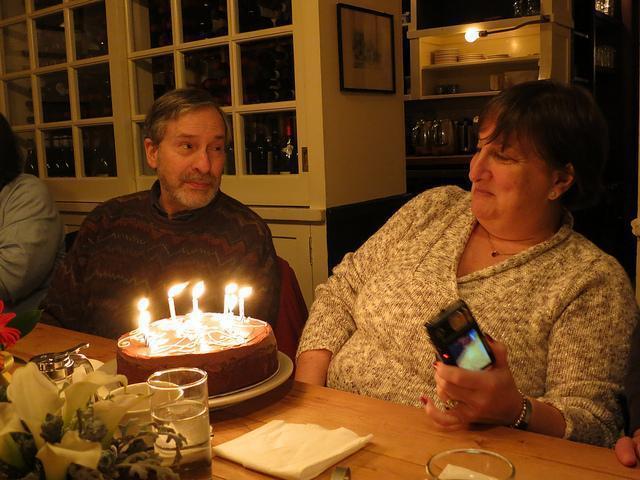How many candles are on the cake?
Give a very brief answer. 8. How many people can be seen?
Give a very brief answer. 3. How many cell phones are in the picture?
Give a very brief answer. 1. How many train cars are orange?
Give a very brief answer. 0. 